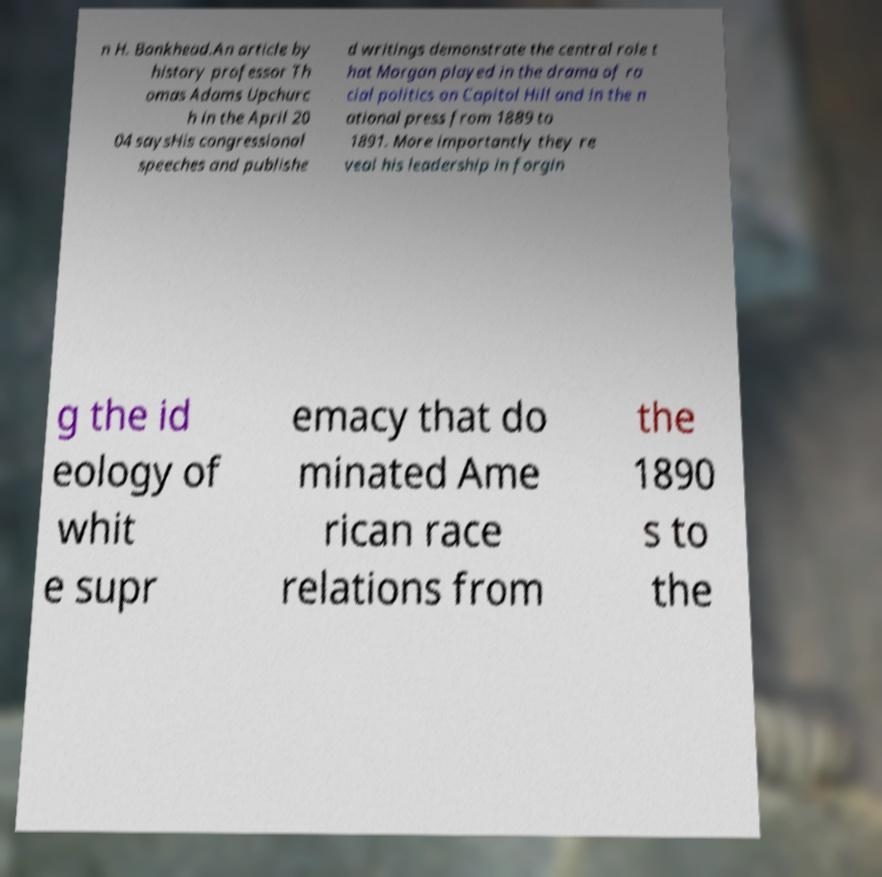Please identify and transcribe the text found in this image. n H. Bankhead.An article by history professor Th omas Adams Upchurc h in the April 20 04 saysHis congressional speeches and publishe d writings demonstrate the central role t hat Morgan played in the drama of ra cial politics on Capitol Hill and in the n ational press from 1889 to 1891. More importantly they re veal his leadership in forgin g the id eology of whit e supr emacy that do minated Ame rican race relations from the 1890 s to the 